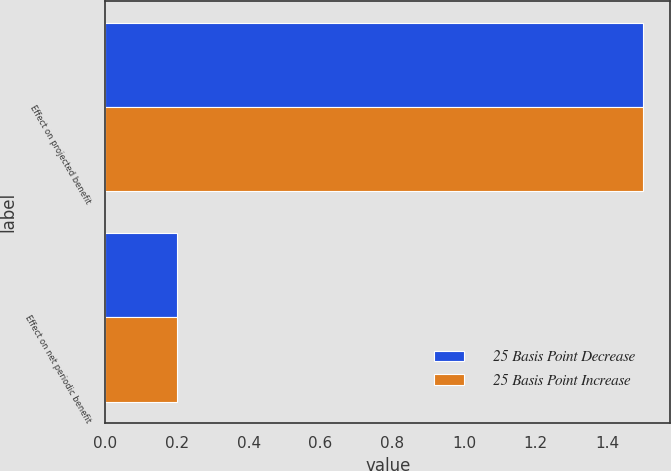Convert chart. <chart><loc_0><loc_0><loc_500><loc_500><stacked_bar_chart><ecel><fcel>Effect on projected benefit<fcel>Effect on net periodic benefit<nl><fcel>25 Basis Point Decrease<fcel>1.5<fcel>0.2<nl><fcel>25 Basis Point Increase<fcel>1.5<fcel>0.2<nl></chart> 